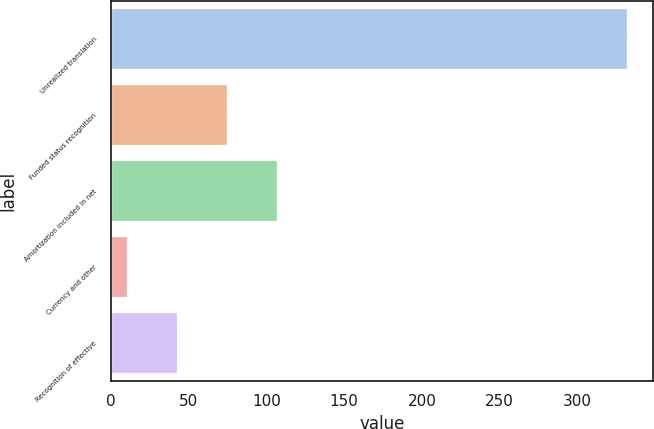<chart> <loc_0><loc_0><loc_500><loc_500><bar_chart><fcel>Unrealized translation<fcel>Funded status recognition<fcel>Amortization included in net<fcel>Currency and other<fcel>Recognition of effective<nl><fcel>332<fcel>74.4<fcel>106.6<fcel>10<fcel>42.2<nl></chart> 